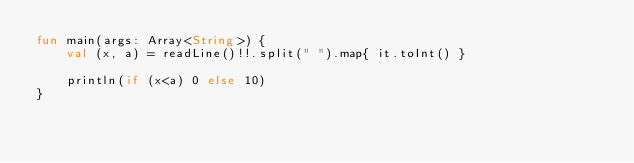Convert code to text. <code><loc_0><loc_0><loc_500><loc_500><_Kotlin_>fun main(args: Array<String>) {
    val (x, a) = readLine()!!.split(" ").map{ it.toInt() }

    println(if (x<a) 0 else 10)
}
</code> 